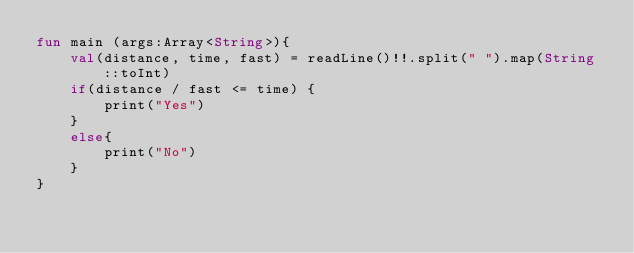<code> <loc_0><loc_0><loc_500><loc_500><_Kotlin_>fun main (args:Array<String>){
    val(distance, time, fast) = readLine()!!.split(" ").map(String::toInt)
    if(distance / fast <= time) {
        print("Yes")
    }
    else{
        print("No")
    }
}</code> 